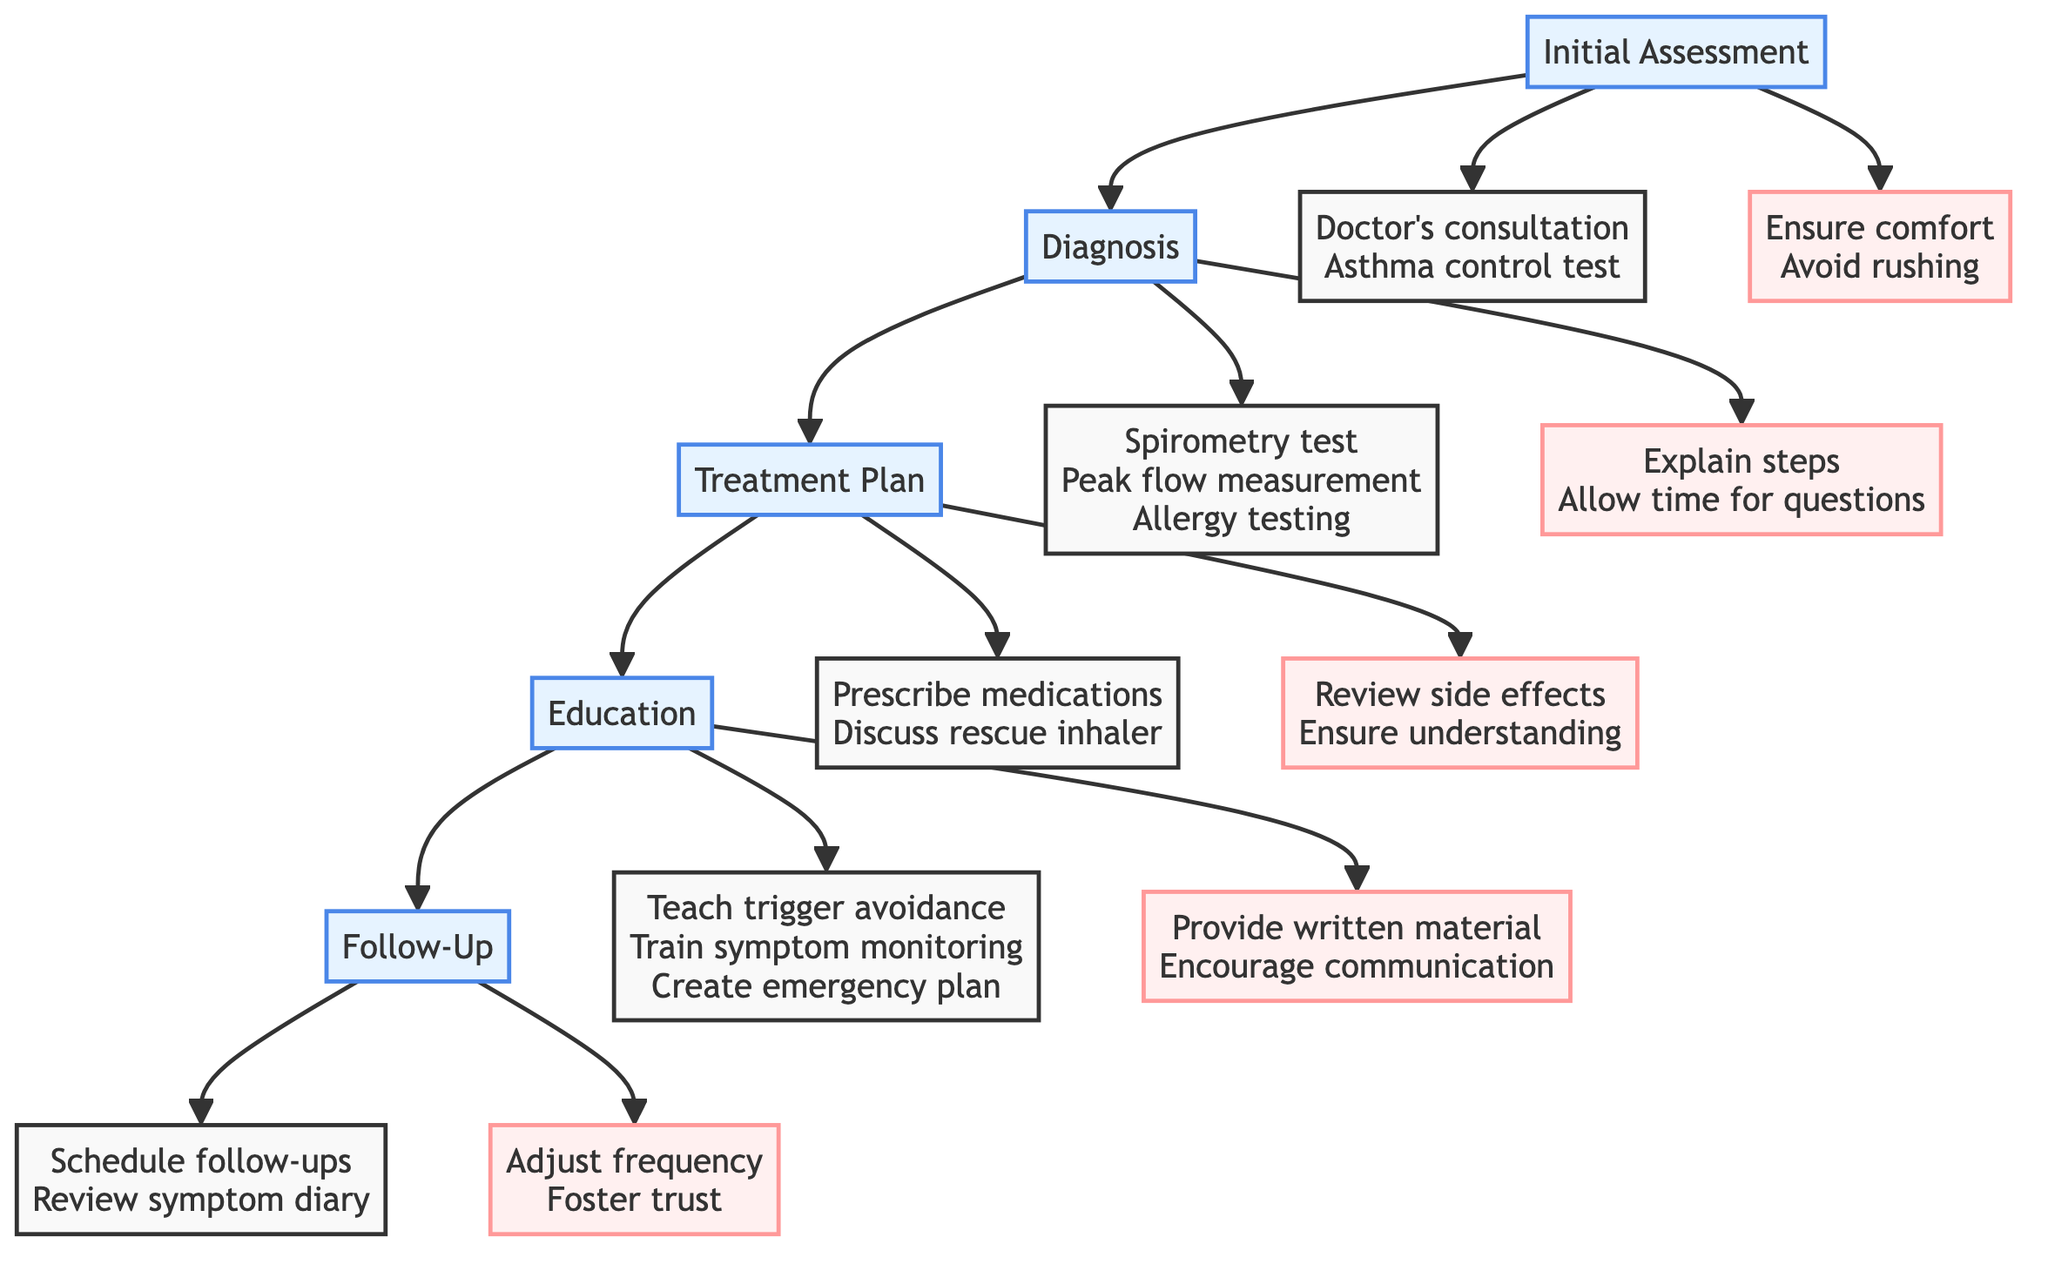What is the first step in the clinical pathway? The first step listed in the clinical pathway is "Initial Assessment." This can be seen at the top of the flowchart, which outlines the sequential steps for managing pediatric asthma.
Answer: Initial Assessment How many key actions are associated with the "Diagnosis" step? In the "Diagnosis" step, there are three key actions: "Spirometry test," "Peak flow measurement," and "Allergy testing." These actions are connected directly from the "Diagnosis" node in the diagram.
Answer: 3 What caution point is related to the "Education" step? One of the caution points under the "Education" step is "Provide written material." This caution point is linked from the "Education" node and emphasizes the need to offer additional resources for understanding asthma management.
Answer: Provide written material What is the last step in the clinical pathway? The last step indicated in the clinical pathway is "Follow-Up." This is positioned at the end of the flow, indicating that it follows all the prior steps in managing pediatric asthma.
Answer: Follow-Up What key action is recommended after "Initial Assessment"? After the "Initial Assessment," the first key action is to conduct a "Doctor's consultation." This action directly flows from the "Initial Assessment" step and is essential for further diagnosis.
Answer: Doctor's consultation Which step includes "Create an emergency plan" as a key action? The key action "Create an emergency plan" is included in the "Education" step. This detail highlights the importance of preparation for asthma emergencies as part of patient education.
Answer: Education How many total steps are there in the clinical pathway? The clinical pathway consists of five total steps: "Initial Assessment," "Diagnosis," "Treatment Plan," "Education," and "Follow-Up." Each step outlines a crucial part of the asthma management process.
Answer: 5 What is the caution point under the "Follow-Up" step? One caution point under the "Follow-Up" step is "Adjust frequency based on needs." This suggests that the follow-up schedule should be tailored according to the individual’s requirements for asthma management.
Answer: Adjust frequency based on needs What two key actions are recommended in the "Treatment Plan"? The two key actions recommended in the "Treatment Plan" are "Prescribe controller medications" and "Discuss rescue inhaler use." These actions focus on the development of an effective treatment strategy for pediatric asthma.
Answer: Prescribe controller medications, Discuss rescue inhaler use 